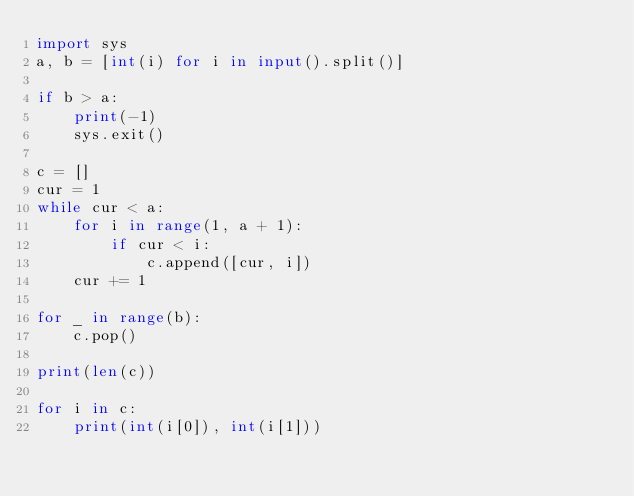<code> <loc_0><loc_0><loc_500><loc_500><_Python_>import sys
a, b = [int(i) for i in input().split()]

if b > a:
    print(-1)
    sys.exit()

c = []
cur = 1
while cur < a:
    for i in range(1, a + 1):
        if cur < i:
            c.append([cur, i])
    cur += 1

for _ in range(b):
    c.pop()

print(len(c))

for i in c:
    print(int(i[0]), int(i[1]))</code> 